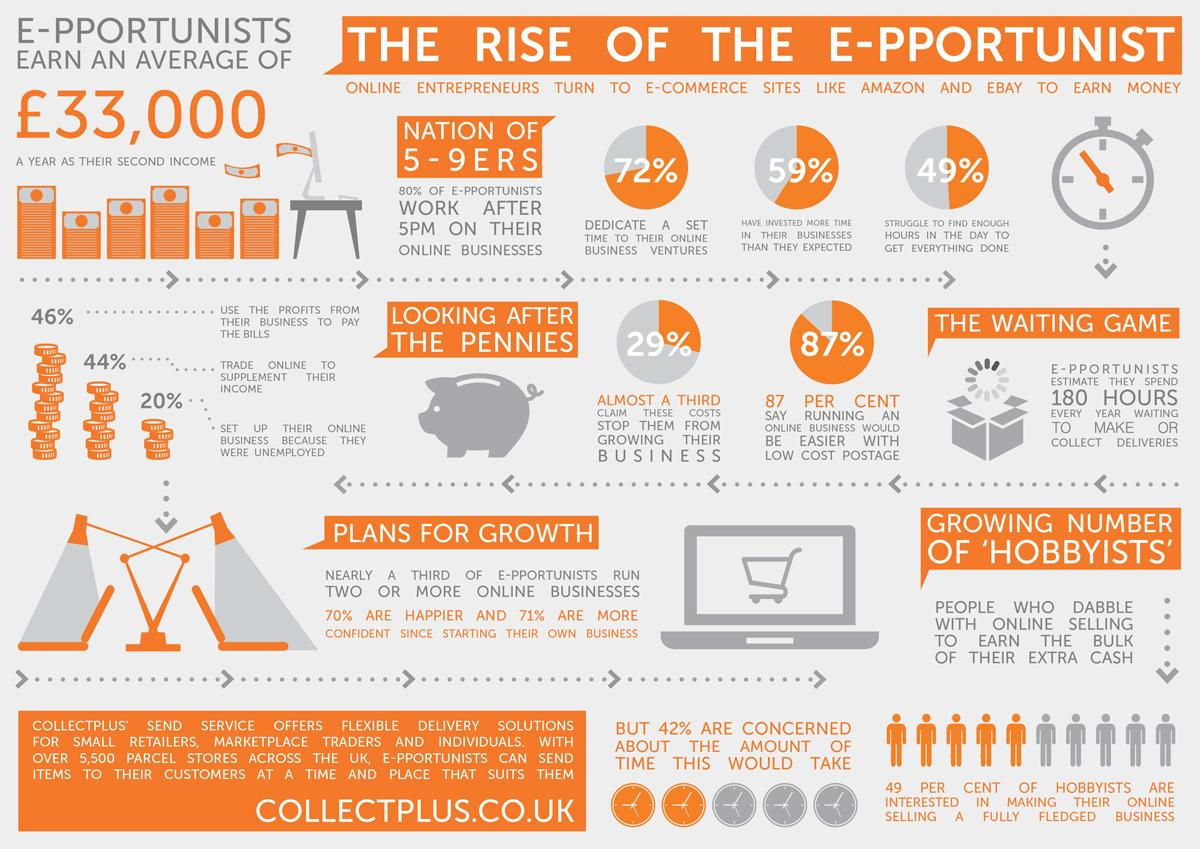Indicate a few pertinent items in this graphic. A survey of e-portfolios in the UK found that 59% of e-pportunists have invested more time in their business than they expected. According to the survey, 49% of E-pportunists in the UK report struggling to find enough hours in the day to complete all their tasks. According to a study conducted in the UK, 72% of E-pportunists dedicate a set time to their online business ventures. According to a recent study, 44% of E-pportunists in the UK trade online to supplement their income. The average annual earnings of e-portfolios among e-portunists in the UK is approximately £33,000. 